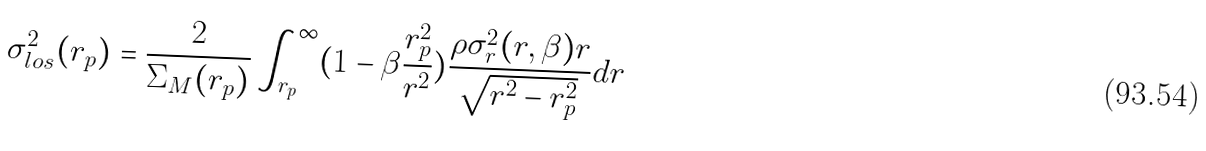<formula> <loc_0><loc_0><loc_500><loc_500>\sigma _ { l o s } ^ { 2 } ( r _ { p } ) = \frac { 2 } { \Sigma _ { M } ( r _ { p } ) } \int _ { r _ { p } } ^ { \infty } ( 1 - \beta \frac { r _ { p } ^ { 2 } } { r ^ { 2 } } ) \frac { \rho \sigma _ { r } ^ { 2 } ( r , \beta ) r } { \sqrt { r ^ { 2 } - r _ { p } ^ { 2 } } } d r</formula> 